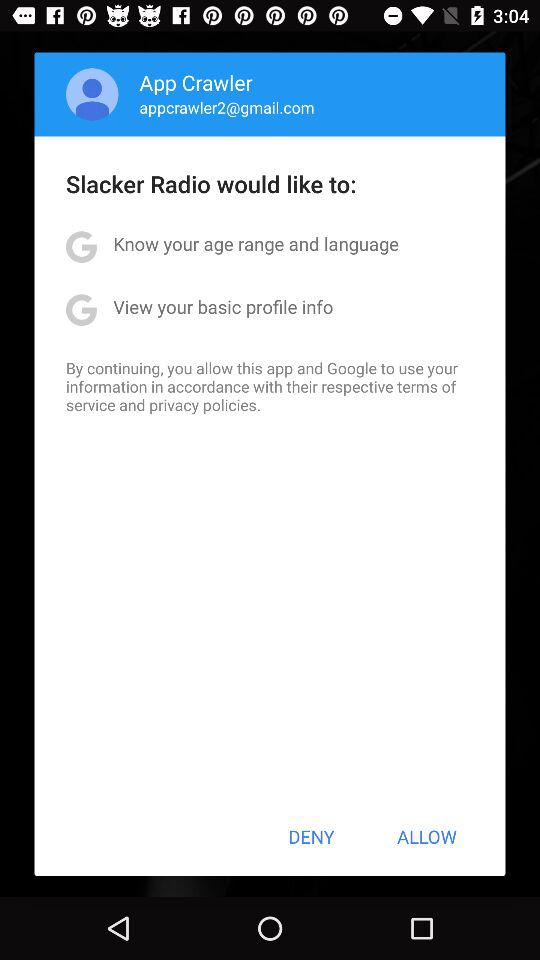How many permissions does Slacker Radio want?
Answer the question using a single word or phrase. 2 